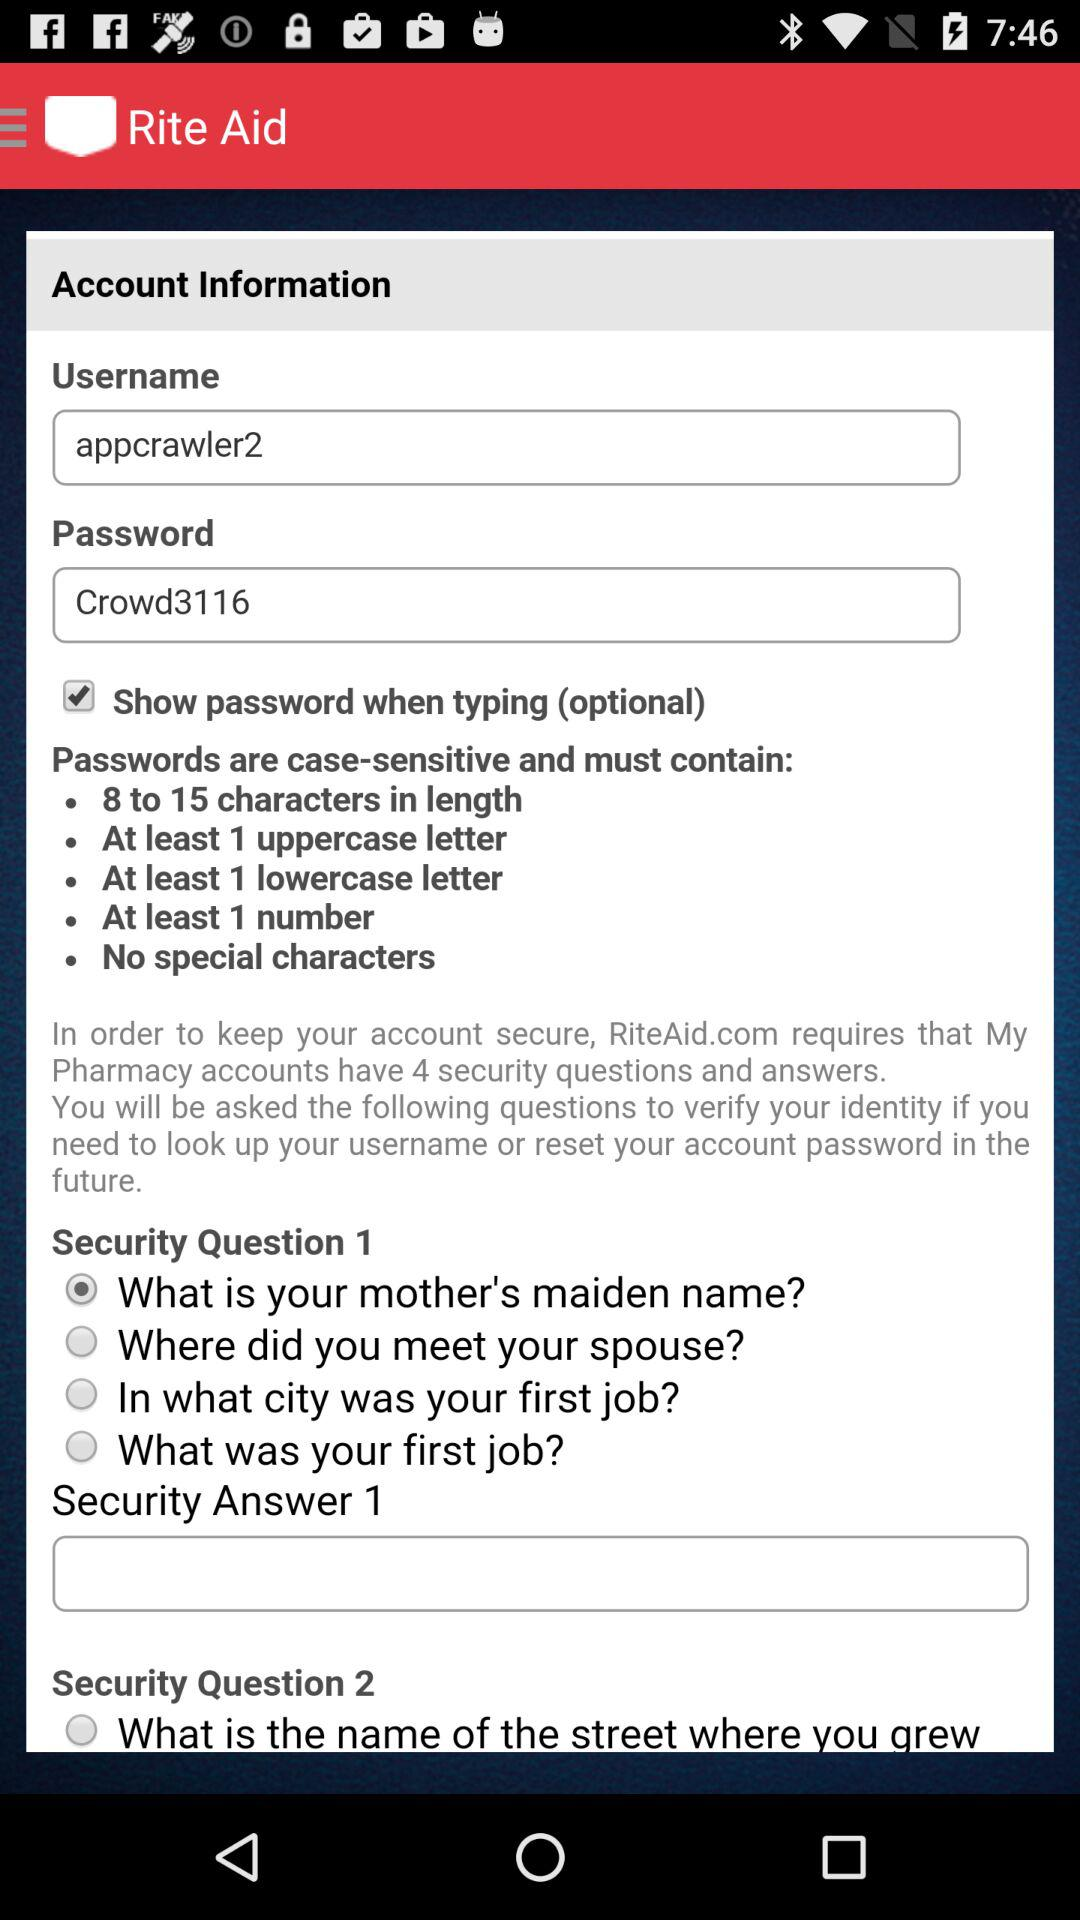Is "What is your mother's maiden name?" selected or not?
Answer the question using a single word or phrase. It is selected. 